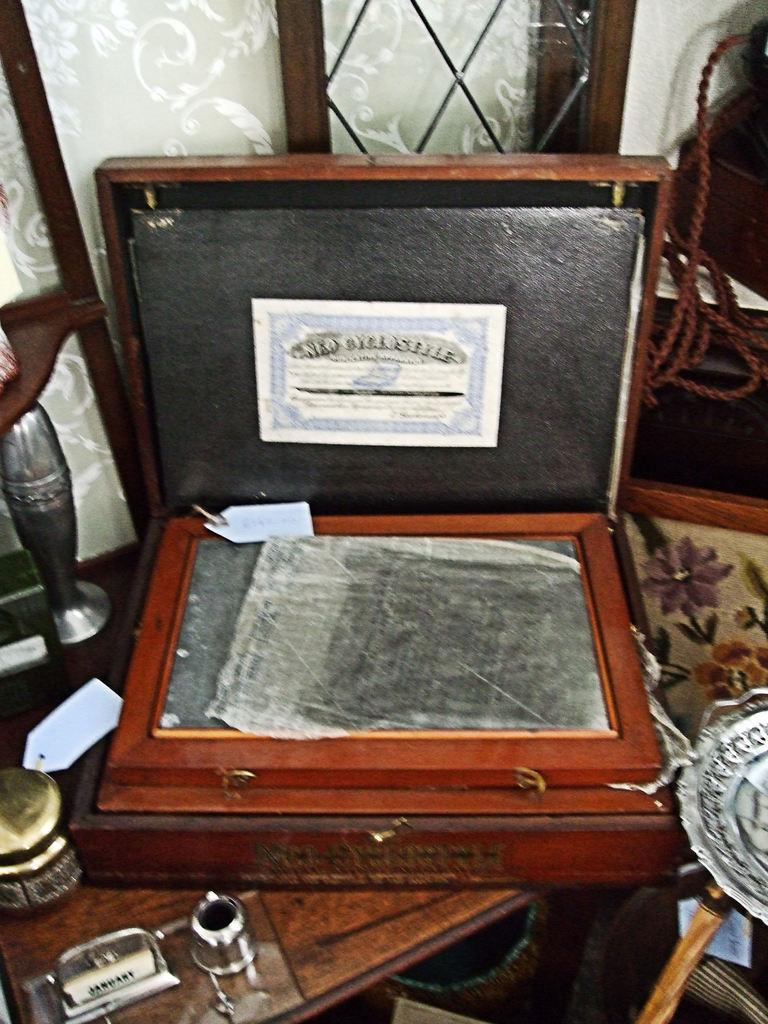What object can be seen in the image? There is a suitcase in the image. Where is the suitcase located? The suitcase is on a wooden table. How many horses are visible in the image? There are no horses present in the image. 